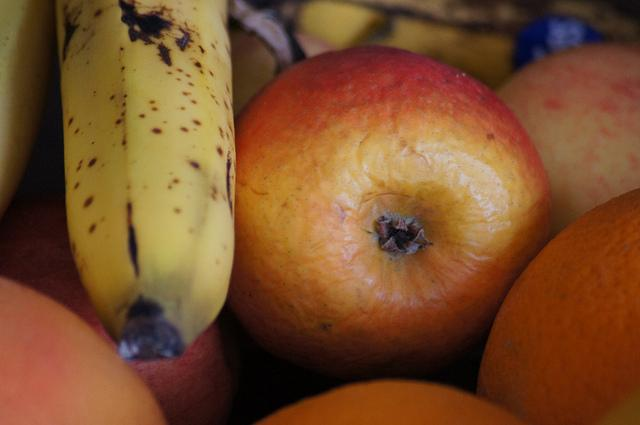What is the color of the fruit in the center of the pile? red 